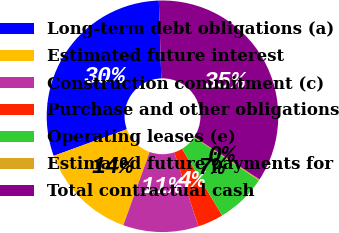Convert chart to OTSL. <chart><loc_0><loc_0><loc_500><loc_500><pie_chart><fcel>Long-term debt obligations (a)<fcel>Estimated future interest<fcel>Construction commitment (c)<fcel>Purchase and other obligations<fcel>Operating leases (e)<fcel>Estimated future payments for<fcel>Total contractual cash<nl><fcel>30.05%<fcel>13.96%<fcel>10.51%<fcel>3.6%<fcel>7.05%<fcel>0.15%<fcel>34.68%<nl></chart> 